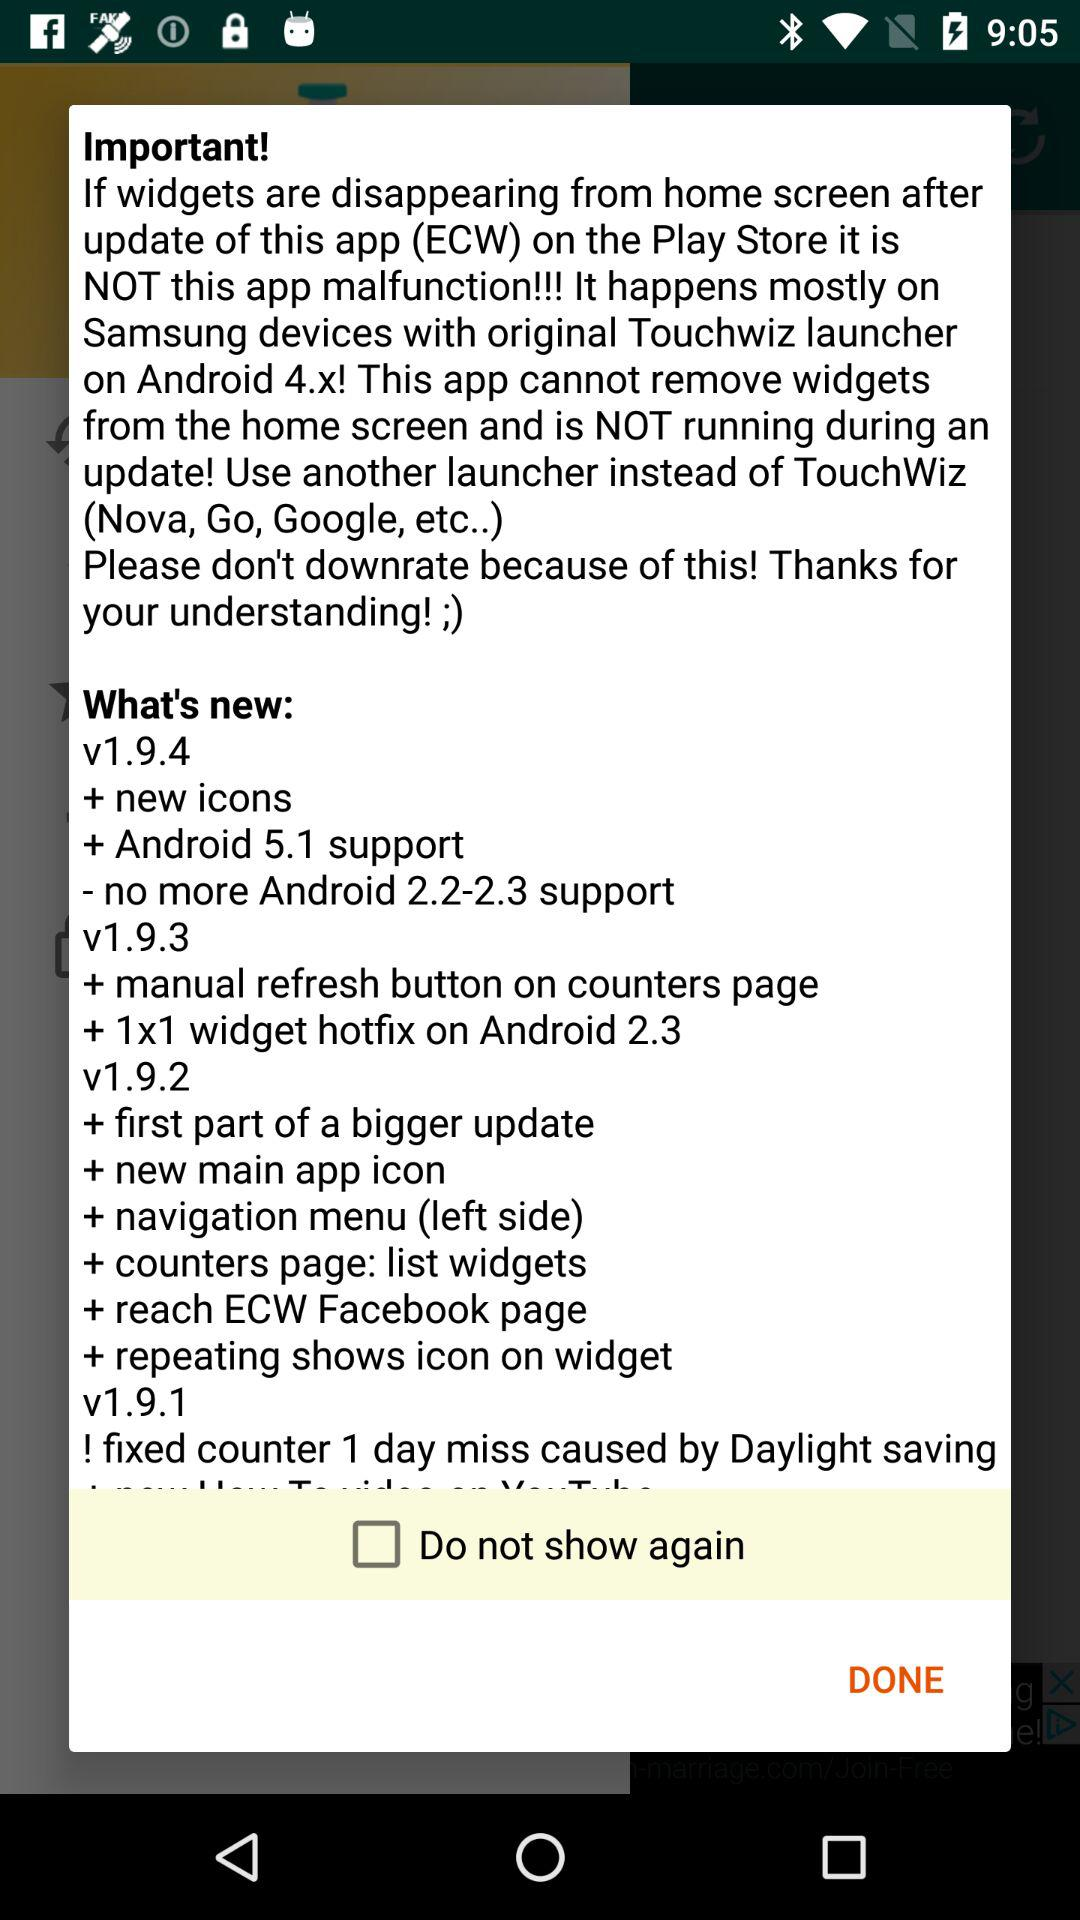What is the current status of the "Do not show again" option? The current status of the "Do not show again" option is "off". 